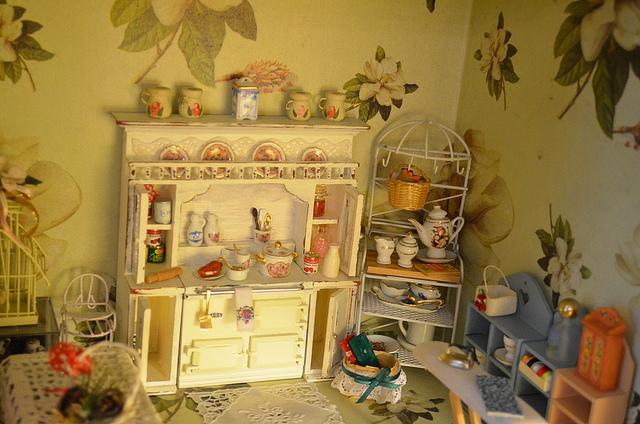Is this furniture for a dollhouse?
Write a very short answer. Yes. Can you see a tea set?
Answer briefly. Yes. How many flowers are on the wall?
Keep it brief. 10. 